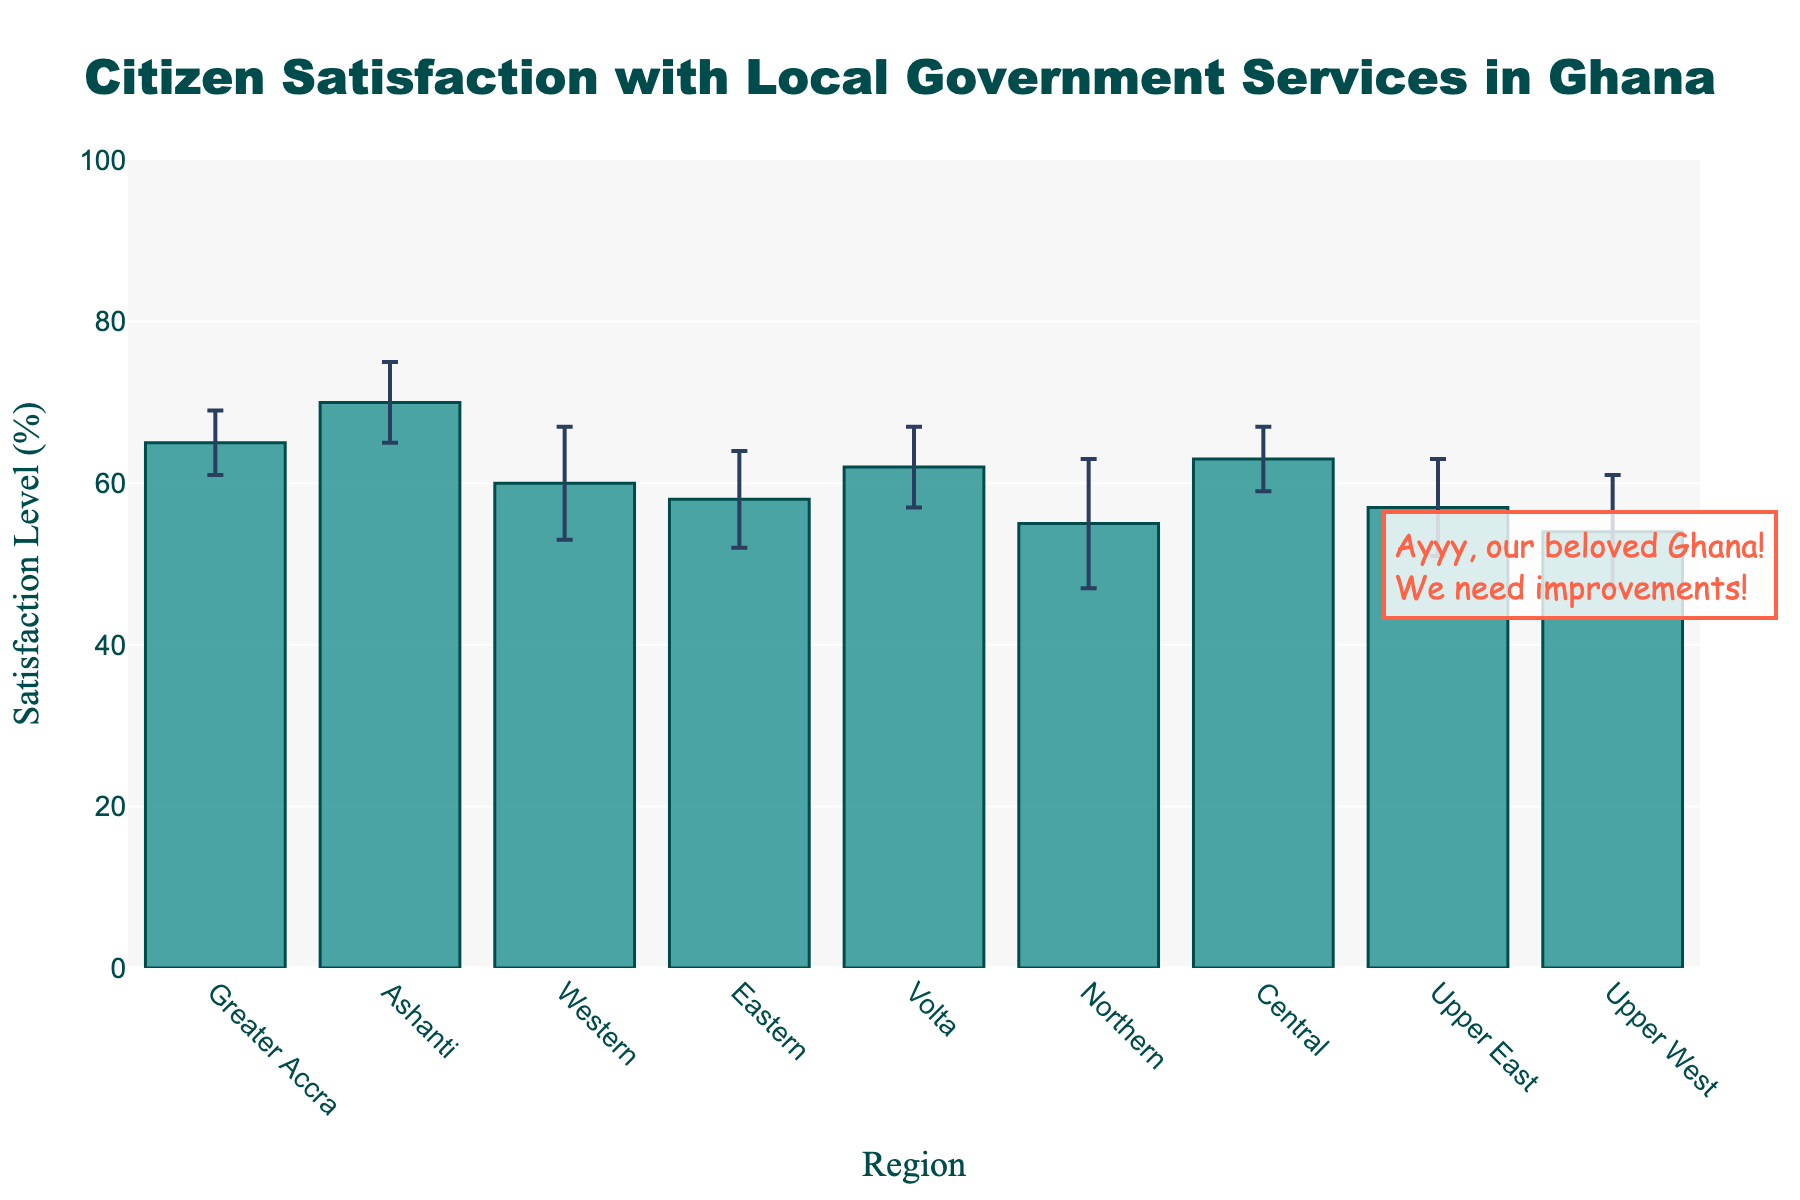How many regions are included in the chart? The chart includes bars representing "Citizen Satisfaction Levels" for different regions in Ghana. We can count these bars to determine the number of regions included.
Answer: 9 What is the title of the chart? The chart has a visible title at the top. Read the title text directly from the chart.
Answer: Citizen Satisfaction with Local Government Services in Ghana Which region has the highest citizen satisfaction level? Look at the top of each bar to see which one reaches the highest point along the y-axis, which indicates the satisfaction level.
Answer: Ashanti What is the difference in citizen satisfaction between the Northern and Greater Accra regions? Identify the satisfaction levels for Northern and Greater Accra regions, then subtract the smaller value from the larger value. Northern is at 55%, and Greater Accra is at 65%. Subtract them to get the difference.
Answer: 10% Which region has the largest error margin in citizen satisfaction? The error bars indicate the standard deviation. Look at their length to determine which one is the longest.
Answer: Northern Compare the satisfaction levels of the Volta and Central regions. Look at the heights of the bars for both the Volta and Central regions and compare them. Volta is at 62%, and Central is at 63%.
Answer: Central is slightly higher What is the combined satisfaction level of the Western and Eastern regions? Identify the satisfaction levels for the Western and Eastern regions, which are 60% and 58%, respectively. Add them together to get the combined value.
Answer: 118% Does any region have a satisfaction level below 55%? Identify the satisfaction levels of all regions from the chart and check if any are below 55%. Only the Upper West region is at 54%.
Answer: Yes, the Upper West region What is the average satisfaction level across all regions? Add up the satisfaction levels for all the regions: 65 + 70 + 60 + 58 + 62 + 55 + 63 + 57 + 54 = 544. Then, divide by the number of regions (9) to get the average.
Answer: Approximately 60.44% What does the annotation in the figure say? The chart has a visible annotation outside the main plot area. Read the text highlighted in the annotation.
Answer: Ayyy, our beloved Ghana! We need improvements! 